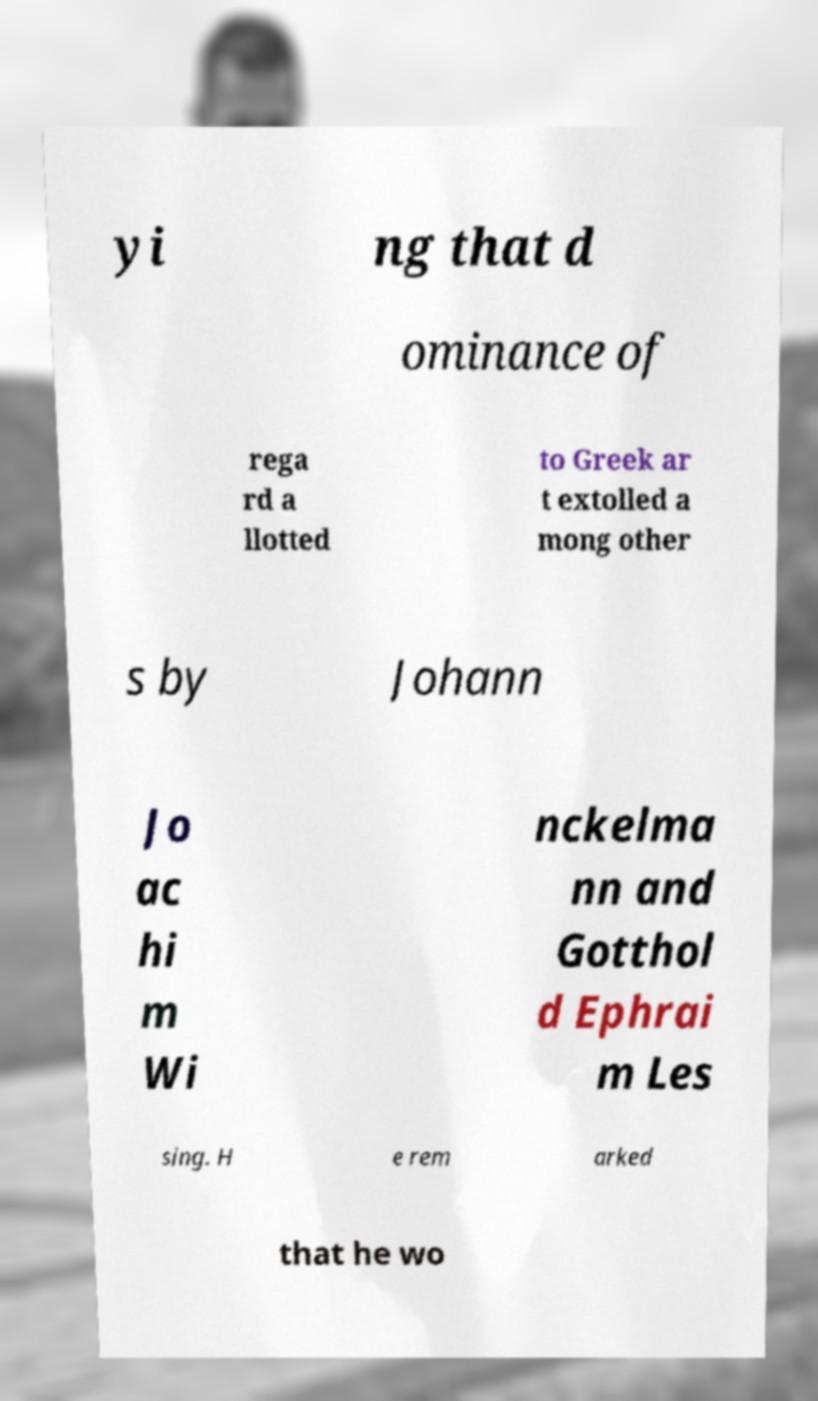I need the written content from this picture converted into text. Can you do that? yi ng that d ominance of rega rd a llotted to Greek ar t extolled a mong other s by Johann Jo ac hi m Wi nckelma nn and Gotthol d Ephrai m Les sing. H e rem arked that he wo 